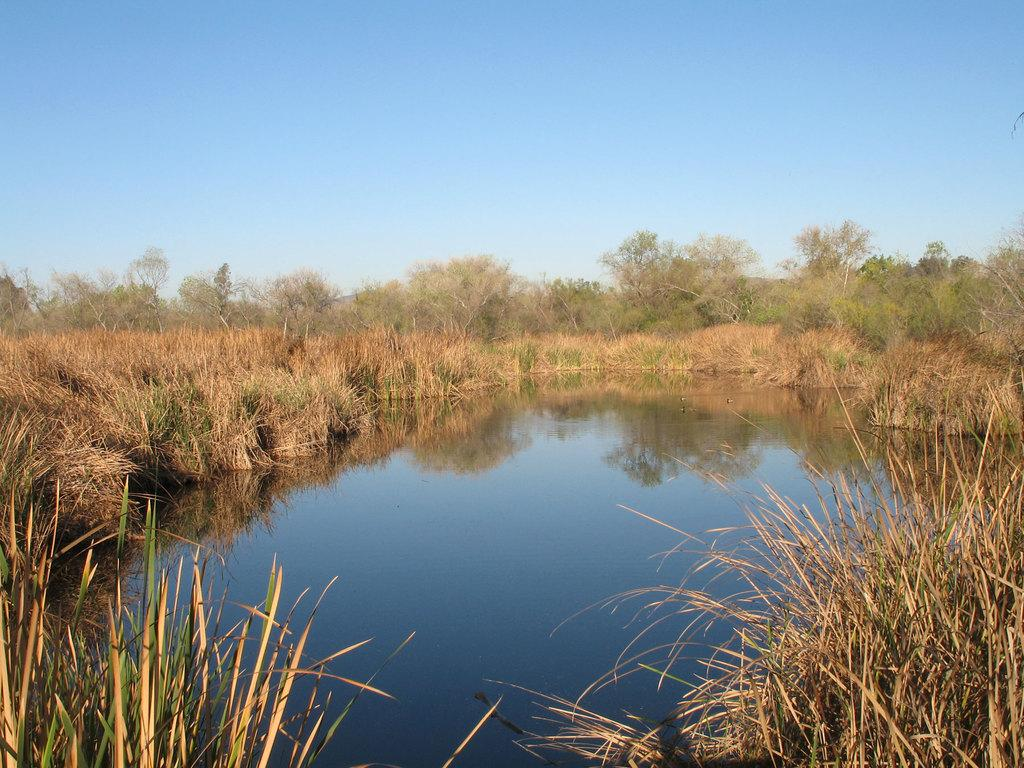What can be seen in the image that is fluid or liquid? There is water visible in the image. What type of vegetation can be seen in the background of the image? There are dried grass in brown color and trees in green color in the background. What is the color of the sky in the image? The sky is blue in color. What flavor of sweater is being worn by the person in the image? There is no person or sweater present in the image. How many trucks can be seen in the image? There are no trucks visible in the image. 